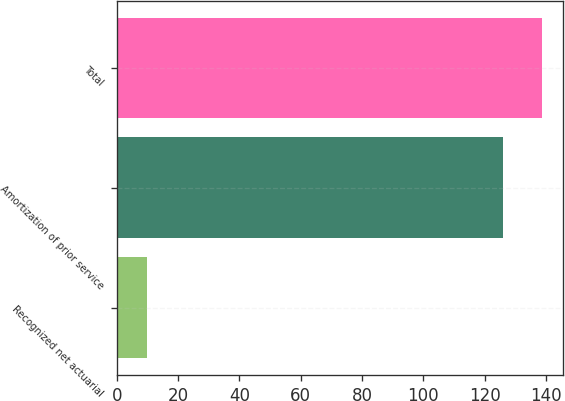<chart> <loc_0><loc_0><loc_500><loc_500><bar_chart><fcel>Recognized net actuarial<fcel>Amortization of prior service<fcel>Total<nl><fcel>10<fcel>126<fcel>138.6<nl></chart> 